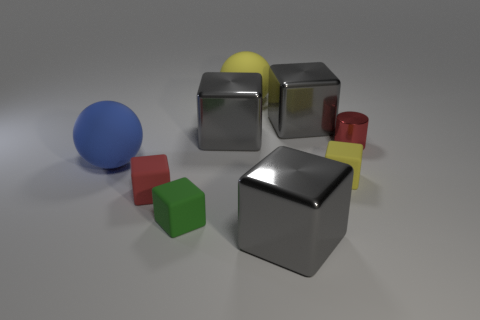How do the different colors of the objects affect the visual composition of the image? The variation in color creates a visually compelling scene by providing contrast and delineating the objects from one another. The primary colors red, blue, yellow, and green provide a bold and simplistic aesthetic, while the silver and grey tones offer a neutral balance, resulting in a harmonious composition. 